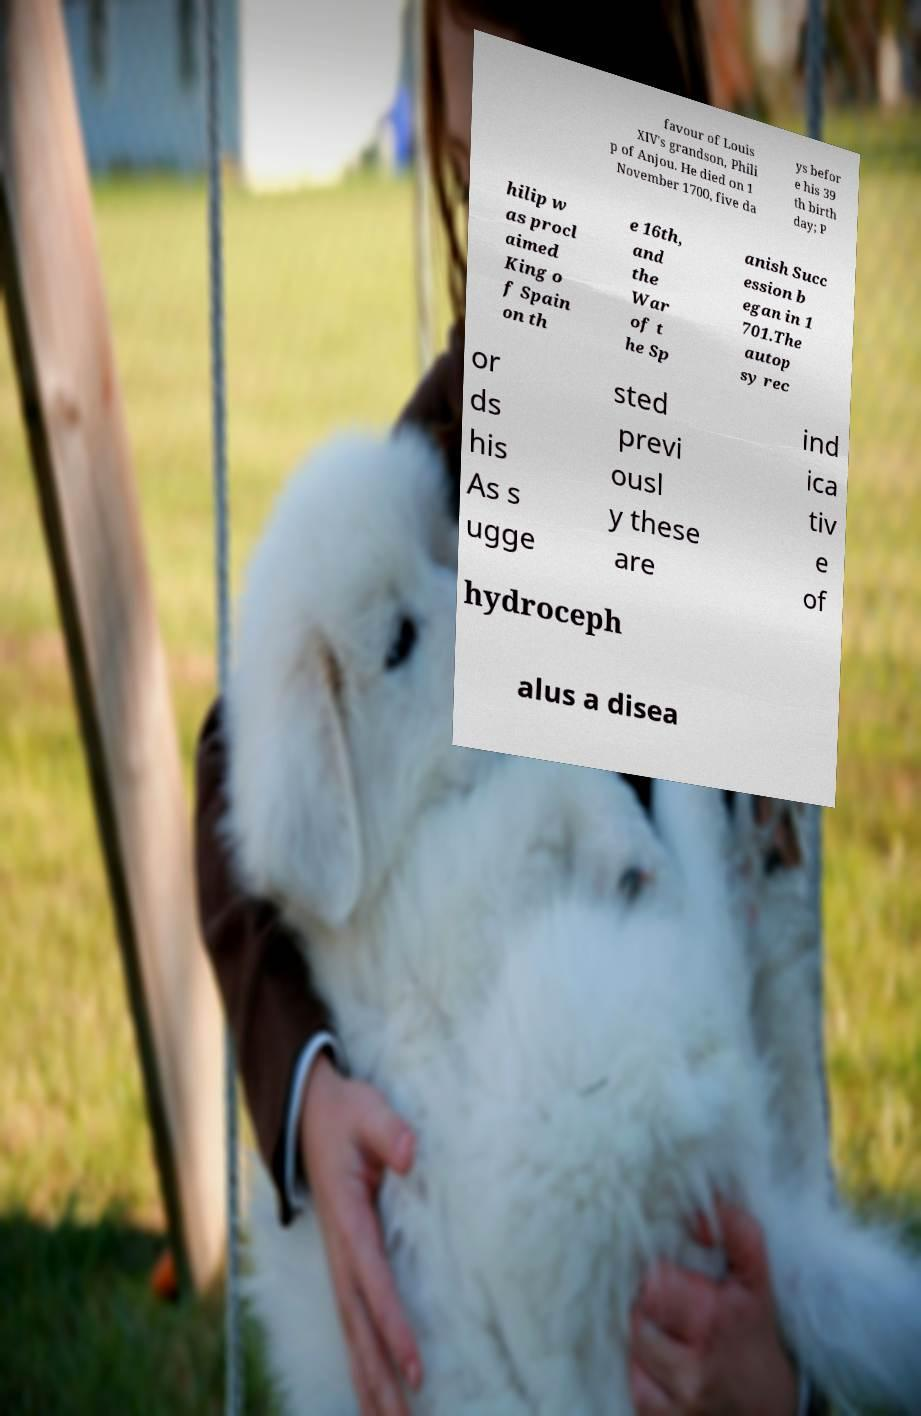Could you assist in decoding the text presented in this image and type it out clearly? favour of Louis XIV's grandson, Phili p of Anjou. He died on 1 November 1700, five da ys befor e his 39 th birth day; P hilip w as procl aimed King o f Spain on th e 16th, and the War of t he Sp anish Succ ession b egan in 1 701.The autop sy rec or ds his As s ugge sted previ ousl y these are ind ica tiv e of hydroceph alus a disea 